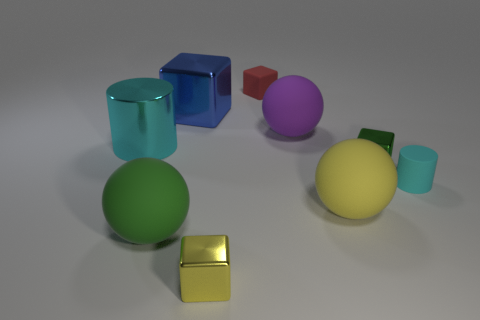Subtract all green metallic cubes. How many cubes are left? 3 Subtract 2 cubes. How many cubes are left? 2 Subtract all yellow cubes. How many cubes are left? 3 Subtract all blocks. How many objects are left? 5 Add 2 small red cubes. How many small red cubes exist? 3 Subtract 0 brown cylinders. How many objects are left? 9 Subtract all brown blocks. Subtract all cyan spheres. How many blocks are left? 4 Subtract all large gray matte cylinders. Subtract all large purple spheres. How many objects are left? 8 Add 6 tiny matte things. How many tiny matte things are left? 8 